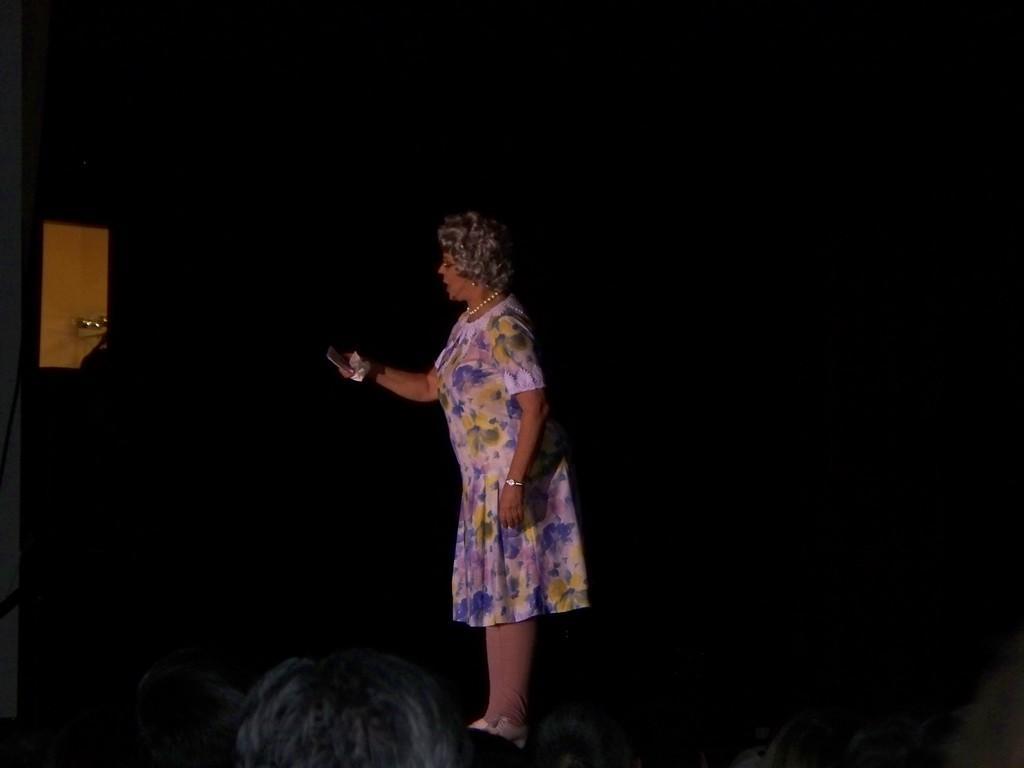Can you describe this image briefly? This is an image clicked in the dark. In the middle of the image I can see a woman wearing a frock, holding a mobile in the hands and looking at the mobile. She is standing facing towards the left side. At the bottom of the image I can see few people are looking at this woman. The background is in black color. 